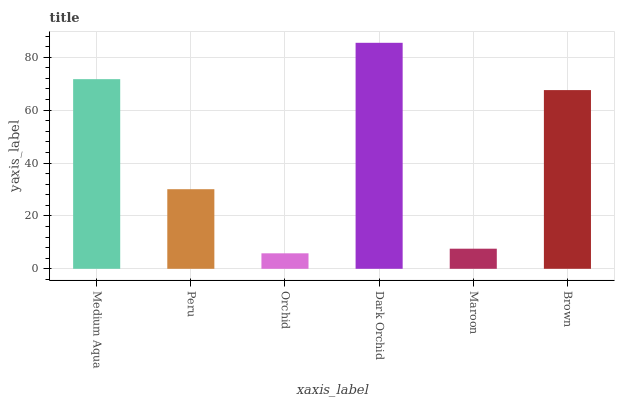Is Orchid the minimum?
Answer yes or no. Yes. Is Dark Orchid the maximum?
Answer yes or no. Yes. Is Peru the minimum?
Answer yes or no. No. Is Peru the maximum?
Answer yes or no. No. Is Medium Aqua greater than Peru?
Answer yes or no. Yes. Is Peru less than Medium Aqua?
Answer yes or no. Yes. Is Peru greater than Medium Aqua?
Answer yes or no. No. Is Medium Aqua less than Peru?
Answer yes or no. No. Is Brown the high median?
Answer yes or no. Yes. Is Peru the low median?
Answer yes or no. Yes. Is Dark Orchid the high median?
Answer yes or no. No. Is Dark Orchid the low median?
Answer yes or no. No. 